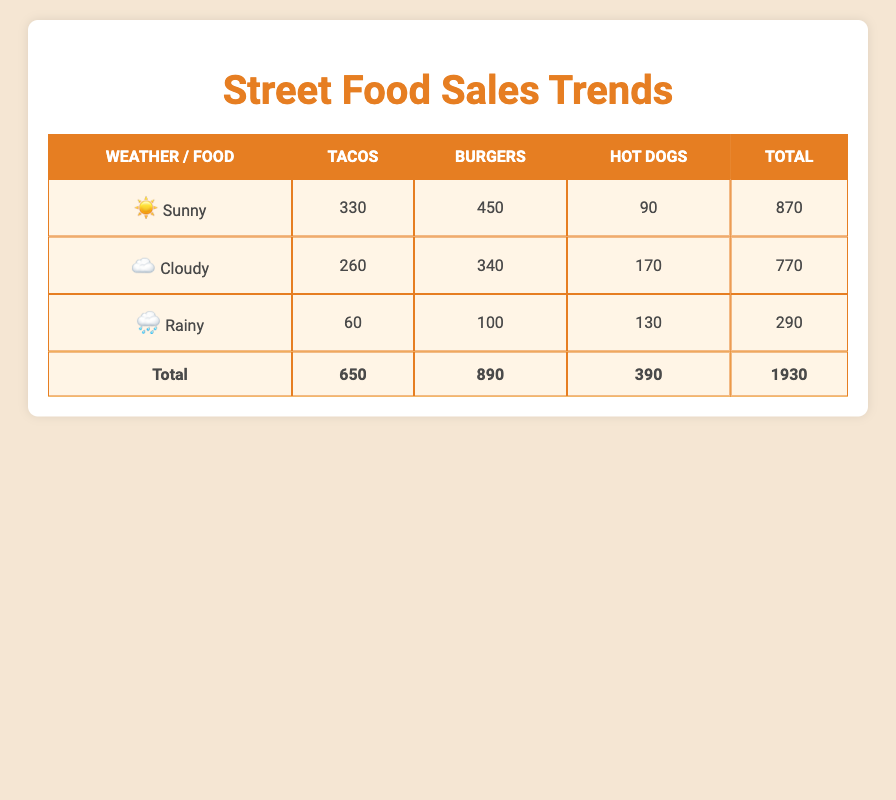What's the total sales for Tacos? To find the total sales for Tacos, I will look at the sales figures for Tacos under each weather condition. Sunny has 330, Cloudy has 260, and Rainy has 60. Adding these together: 330 + 260 + 60 = 650.
Answer: 650 Which food type had the highest sales during Rainy weather? To determine the food type with the highest sales during Rainy weather, I will compare the sales units for each food type under the Rainy condition. Tacos sold 60, Burgers sold 100, and Hot Dogs sold 130. The highest number is 130 for Hot Dogs.
Answer: Hot Dogs What is the total sales for Cloudy weather? I will sum the total sales across all food types under Cloudy weather. For Tacos, the sales are 260, for Burgers it’s 340, and for Hot Dogs it’s 170. Adding these gives: 260 + 340 + 170 = 770.
Answer: 770 Did Burgers sell more than Tacos during Sunny weather? Under Sunny weather, Tacos sold 330 units and Burgers sold 450 units. Since 450 is greater than 330, the answer is yes.
Answer: Yes What is the average sales for Hot Dogs across all weather conditions? First, I need to find the total sales for Hot Dogs under each weather condition: 90 (Sunny) + 70 (Cloudy) + 130 (Rainy) = 290. There are 3 weather conditions, so to find the average, I divide by 3: 290 / 3 = 96.67.
Answer: 96.67 Which food type had the least sales during Cloudy weather? Looking at the Cloudy weather figures, Tacos sold 260, Burgers sold 340, and Hot Dogs sold 170. The lowest sales are from Hot Dogs with 170 units sold.
Answer: Hot Dogs What is the difference in sales between Burgers on Sunny and Rainy days? The sales for Burgers on Sunny days is 450 and on Rainy days is 100. The difference can be calculated as 450 - 100 = 350.
Answer: 350 Was the total sales higher on Sunny days compared to Rainy days? The total sales during Sunny days is 870 (Tacos 330 + Burgers 450 + Hot Dogs 90), and during Rainy days it’s 290 (Tacos 60 + Burgers 100 + Hot Dogs 130). Since 870 is greater than 290, the answer is yes.
Answer: Yes 